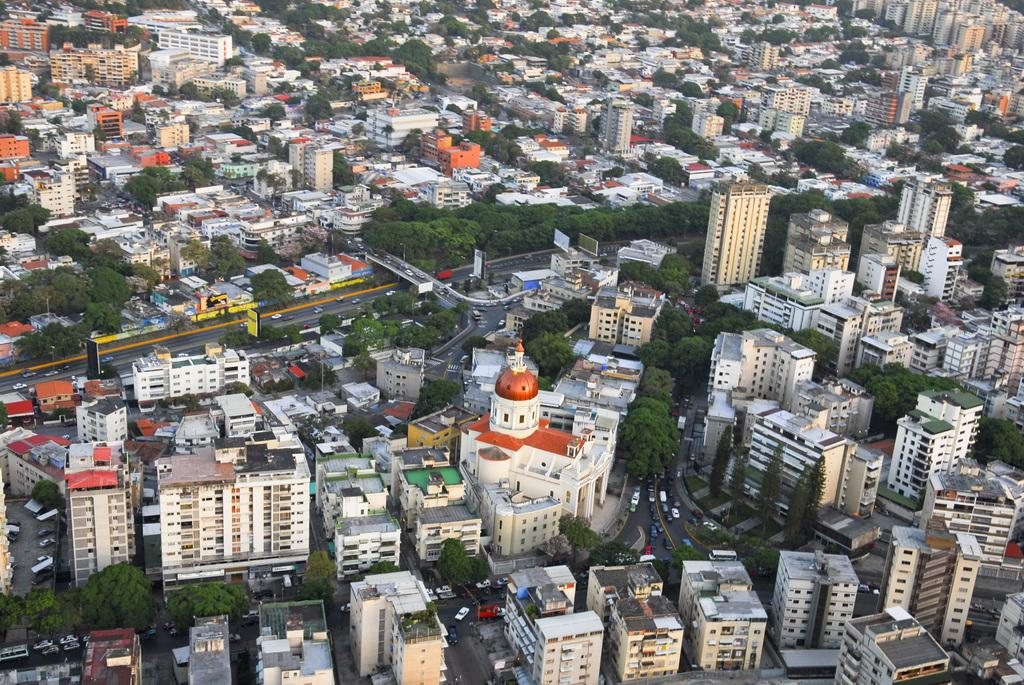What is the main subject of the image? The main subject of the image is an overview of a city. What type of structures can be seen in the image? There are buildings in the image. What type of vegetation is visible in the image? There are trees in the image. What type of transportation infrastructure is present in the image? There are roads in the image. What type of objects can be seen on the roads in the image? There are vehicles on the roads in the image. What is the metal limit for the number of passengers allowed on the trees in the image? There is no metal limit for the number of passengers allowed on the trees in the image, as trees are not vehicles and do not have passenger limits. 